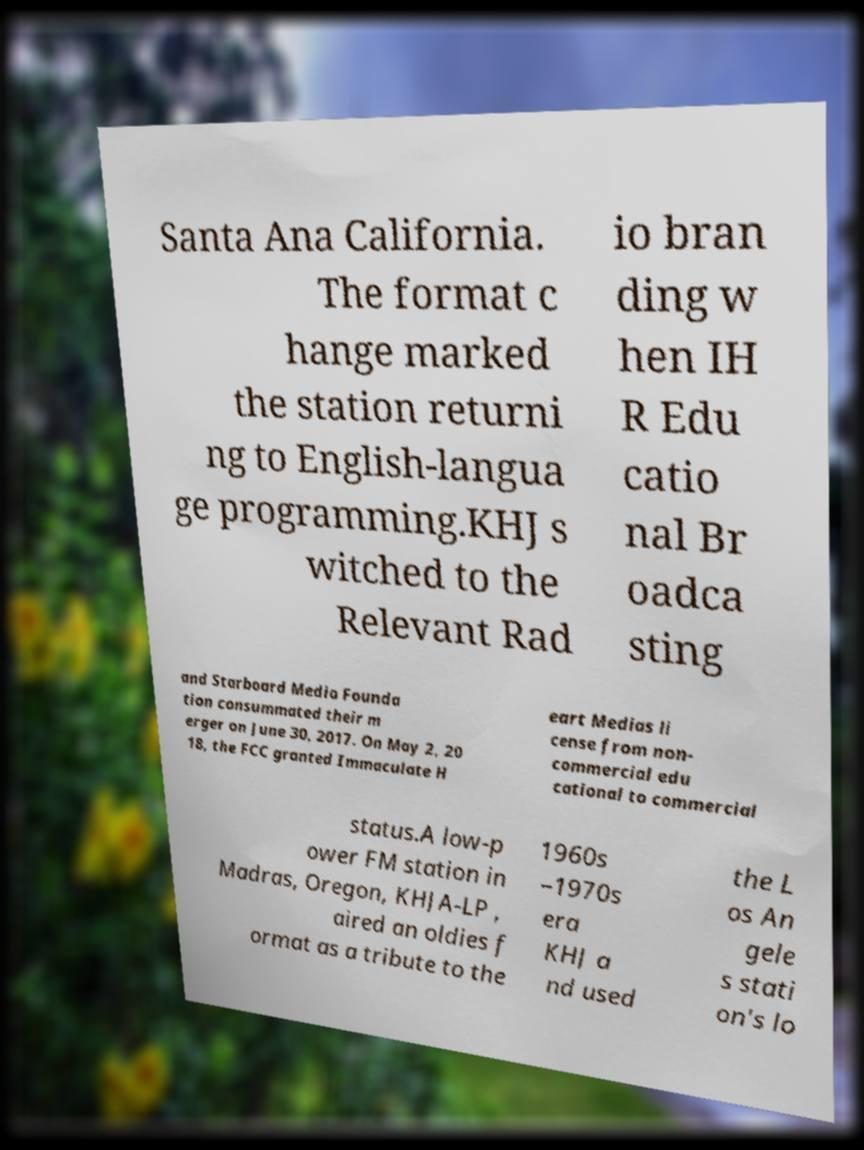Could you assist in decoding the text presented in this image and type it out clearly? Santa Ana California. The format c hange marked the station returni ng to English-langua ge programming.KHJ s witched to the Relevant Rad io bran ding w hen IH R Edu catio nal Br oadca sting and Starboard Media Founda tion consummated their m erger on June 30, 2017. On May 2, 20 18, the FCC granted Immaculate H eart Medias li cense from non- commercial edu cational to commercial status.A low-p ower FM station in Madras, Oregon, KHJA-LP , aired an oldies f ormat as a tribute to the 1960s –1970s era KHJ a nd used the L os An gele s stati on's lo 